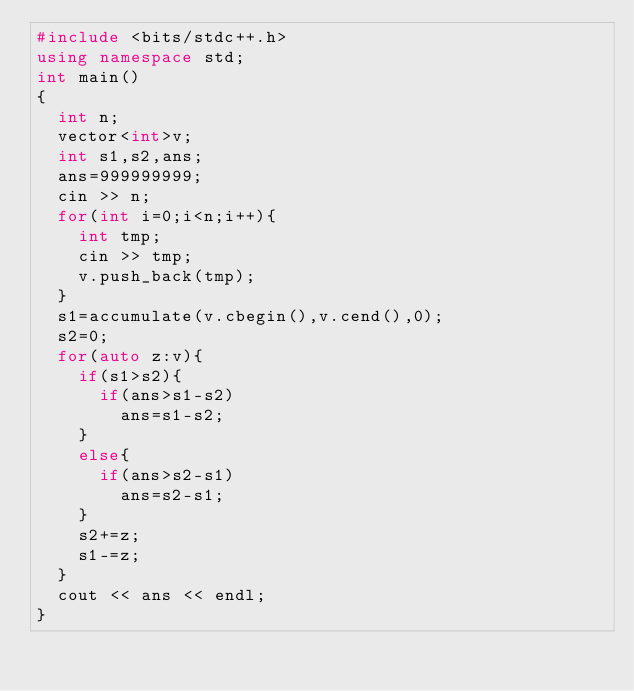<code> <loc_0><loc_0><loc_500><loc_500><_C++_>#include <bits/stdc++.h>
using namespace std;
int main()
{
  int n;
  vector<int>v;
  int s1,s2,ans;
  ans=999999999;
  cin >> n;
  for(int i=0;i<n;i++){
    int tmp;
    cin >> tmp;
    v.push_back(tmp);
  }
  s1=accumulate(v.cbegin(),v.cend(),0);
  s2=0;
  for(auto z:v){
    if(s1>s2){
      if(ans>s1-s2)
        ans=s1-s2;
    }
    else{
      if(ans>s2-s1)
        ans=s2-s1;
    }
    s2+=z;
    s1-=z;
  }
  cout << ans << endl;
}
</code> 